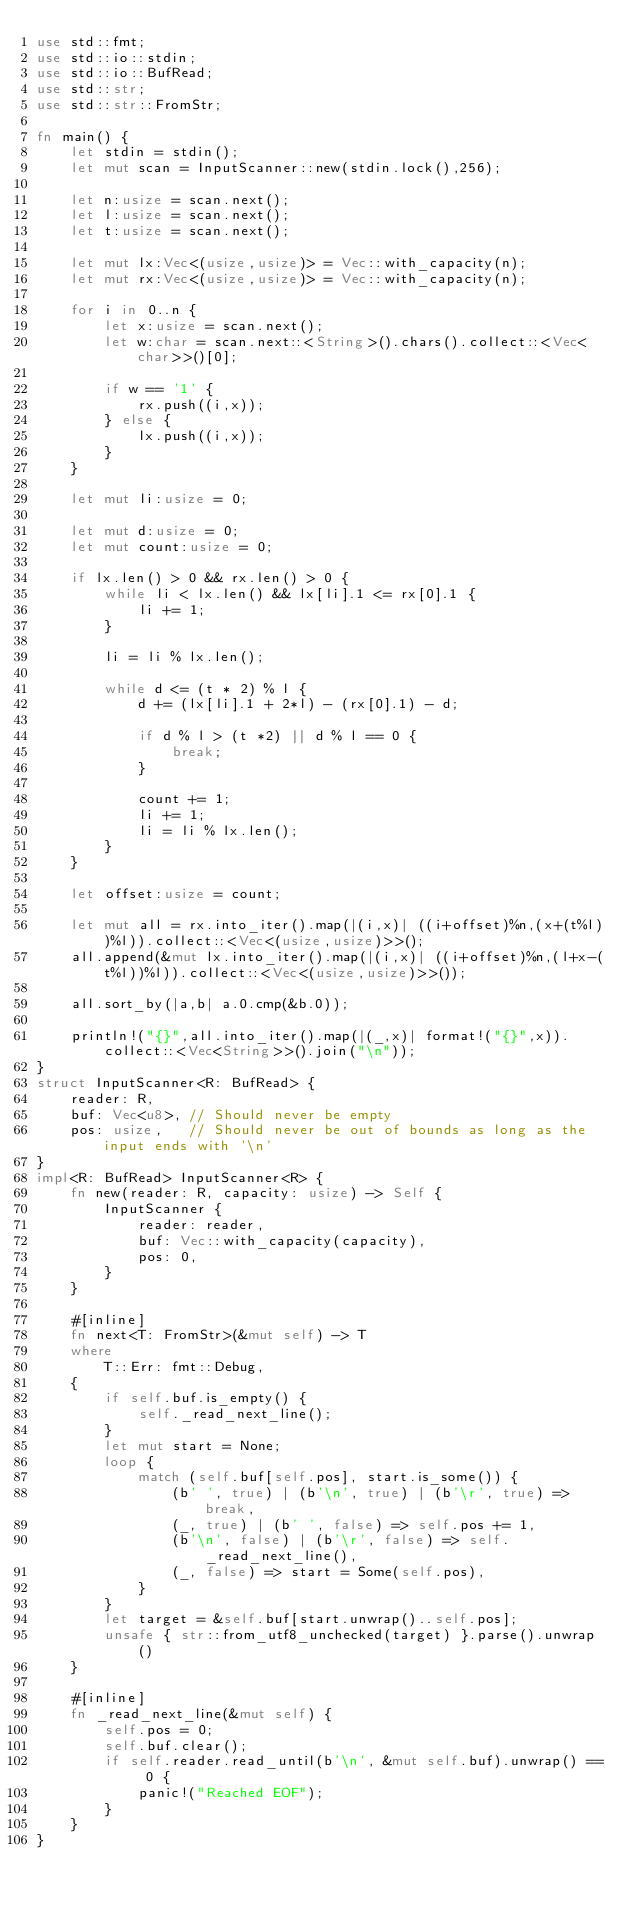<code> <loc_0><loc_0><loc_500><loc_500><_Rust_>use std::fmt;
use std::io::stdin;
use std::io::BufRead;
use std::str;
use std::str::FromStr;

fn main() {
	let stdin = stdin();
	let mut scan = InputScanner::new(stdin.lock(),256);

	let n:usize = scan.next();
	let l:usize = scan.next();
	let t:usize = scan.next();

	let mut lx:Vec<(usize,usize)> = Vec::with_capacity(n);
	let mut rx:Vec<(usize,usize)> = Vec::with_capacity(n);

	for i in 0..n {
		let x:usize = scan.next();
		let w:char = scan.next::<String>().chars().collect::<Vec<char>>()[0];

		if w == '1' {
			rx.push((i,x));
		} else {
			lx.push((i,x));
		}
	}

	let mut li:usize = 0;

	let mut d:usize = 0;
	let mut count:usize = 0;

	if lx.len() > 0 && rx.len() > 0 {
		while li < lx.len() && lx[li].1 <= rx[0].1 {
			li += 1;
		}

		li = li % lx.len();

		while d <= (t * 2) % l {
			d += (lx[li].1 + 2*l) - (rx[0].1) - d;

			if d % l > (t *2) || d % l == 0 {
				break;
			}

			count += 1;
			li += 1;
			li = li % lx.len();
		}
	}

	let offset:usize = count;

	let mut all = rx.into_iter().map(|(i,x)| ((i+offset)%n,(x+(t%l))%l)).collect::<Vec<(usize,usize)>>();
	all.append(&mut lx.into_iter().map(|(i,x)| ((i+offset)%n,(l+x-(t%l))%l)).collect::<Vec<(usize,usize)>>());

	all.sort_by(|a,b| a.0.cmp(&b.0));

	println!("{}",all.into_iter().map(|(_,x)| format!("{}",x)).collect::<Vec<String>>().join("\n"));
}
struct InputScanner<R: BufRead> {
	reader: R,
	buf: Vec<u8>, // Should never be empty
	pos: usize,   // Should never be out of bounds as long as the input ends with '\n'
}
impl<R: BufRead> InputScanner<R> {
	fn new(reader: R, capacity: usize) -> Self {
		InputScanner {
			reader: reader,
			buf: Vec::with_capacity(capacity),
			pos: 0,
		}
	}

	#[inline]
	fn next<T: FromStr>(&mut self) -> T
	where
		T::Err: fmt::Debug,
	{
		if self.buf.is_empty() {
			self._read_next_line();
		}
		let mut start = None;
		loop {
			match (self.buf[self.pos], start.is_some()) {
				(b' ', true) | (b'\n', true) | (b'\r', true) => break,
				(_, true) | (b' ', false) => self.pos += 1,
				(b'\n', false) | (b'\r', false) => self._read_next_line(),
				(_, false) => start = Some(self.pos),
			}
		}
		let target = &self.buf[start.unwrap()..self.pos];
		unsafe { str::from_utf8_unchecked(target) }.parse().unwrap()
	}

	#[inline]
	fn _read_next_line(&mut self) {
		self.pos = 0;
		self.buf.clear();
		if self.reader.read_until(b'\n', &mut self.buf).unwrap() == 0 {
			panic!("Reached EOF");
		}
	}
}

</code> 